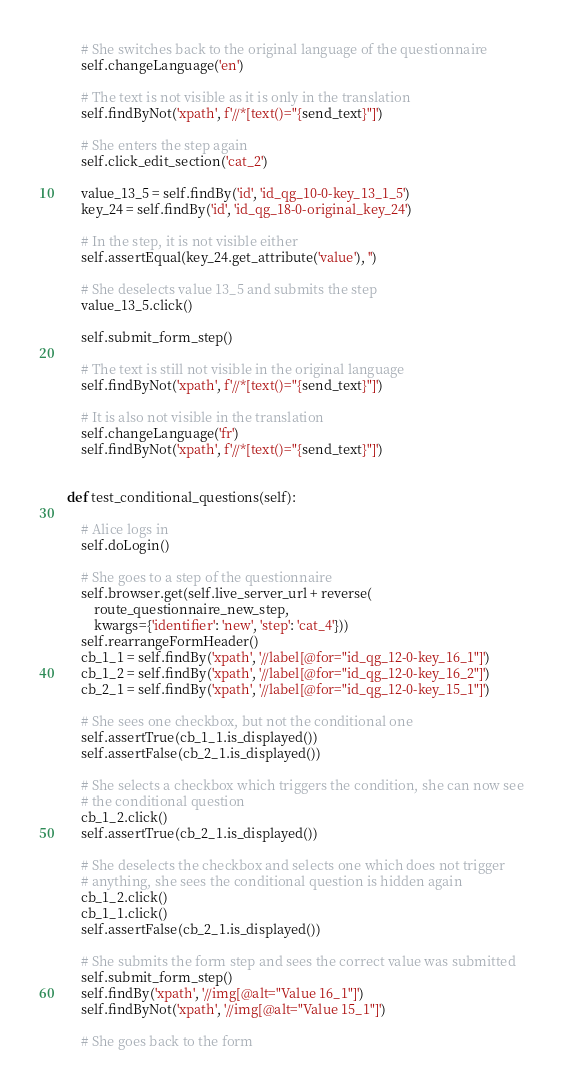Convert code to text. <code><loc_0><loc_0><loc_500><loc_500><_Python_>
        # She switches back to the original language of the questionnaire
        self.changeLanguage('en')

        # The text is not visible as it is only in the translation
        self.findByNot('xpath', f'//*[text()="{send_text}"]')

        # She enters the step again
        self.click_edit_section('cat_2')

        value_13_5 = self.findBy('id', 'id_qg_10-0-key_13_1_5')
        key_24 = self.findBy('id', 'id_qg_18-0-original_key_24')

        # In the step, it is not visible either
        self.assertEqual(key_24.get_attribute('value'), '')

        # She deselects value 13_5 and submits the step
        value_13_5.click()

        self.submit_form_step()

        # The text is still not visible in the original language
        self.findByNot('xpath', f'//*[text()="{send_text}"]')

        # It is also not visible in the translation
        self.changeLanguage('fr')
        self.findByNot('xpath', f'//*[text()="{send_text}"]')


    def test_conditional_questions(self):

        # Alice logs in
        self.doLogin()

        # She goes to a step of the questionnaire
        self.browser.get(self.live_server_url + reverse(
            route_questionnaire_new_step,
            kwargs={'identifier': 'new', 'step': 'cat_4'}))
        self.rearrangeFormHeader()
        cb_1_1 = self.findBy('xpath', '//label[@for="id_qg_12-0-key_16_1"]')
        cb_1_2 = self.findBy('xpath', '//label[@for="id_qg_12-0-key_16_2"]')
        cb_2_1 = self.findBy('xpath', '//label[@for="id_qg_12-0-key_15_1"]')

        # She sees one checkbox, but not the conditional one
        self.assertTrue(cb_1_1.is_displayed())
        self.assertFalse(cb_2_1.is_displayed())

        # She selects a checkbox which triggers the condition, she can now see
        # the conditional question
        cb_1_2.click()
        self.assertTrue(cb_2_1.is_displayed())

        # She deselects the checkbox and selects one which does not trigger
        # anything, she sees the conditional question is hidden again
        cb_1_2.click()
        cb_1_1.click()
        self.assertFalse(cb_2_1.is_displayed())

        # She submits the form step and sees the correct value was submitted
        self.submit_form_step()
        self.findBy('xpath', '//img[@alt="Value 16_1"]')
        self.findByNot('xpath', '//img[@alt="Value 15_1"]')

        # She goes back to the form</code> 